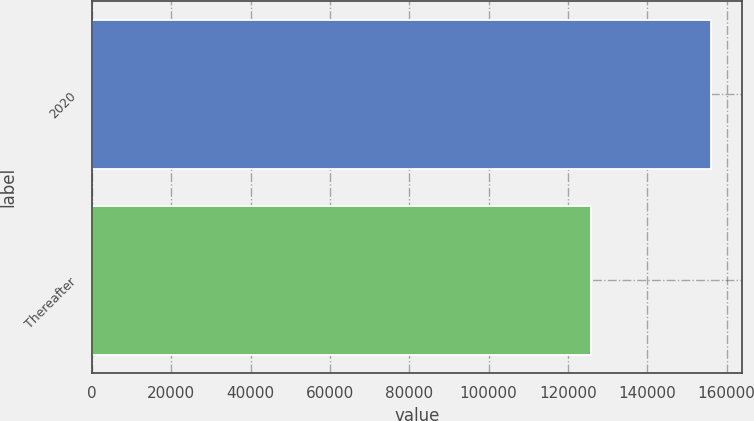Convert chart. <chart><loc_0><loc_0><loc_500><loc_500><bar_chart><fcel>2020<fcel>Thereafter<nl><fcel>156072<fcel>125881<nl></chart> 